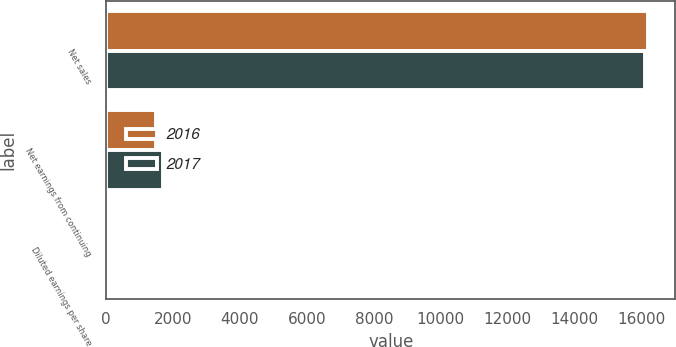Convert chart to OTSL. <chart><loc_0><loc_0><loc_500><loc_500><stacked_bar_chart><ecel><fcel>Net sales<fcel>Net earnings from continuing<fcel>Diluted earnings per share<nl><fcel>2016<fcel>16201<fcel>1482<fcel>2.28<nl><fcel>2017<fcel>16112<fcel>1692<fcel>2.62<nl></chart> 